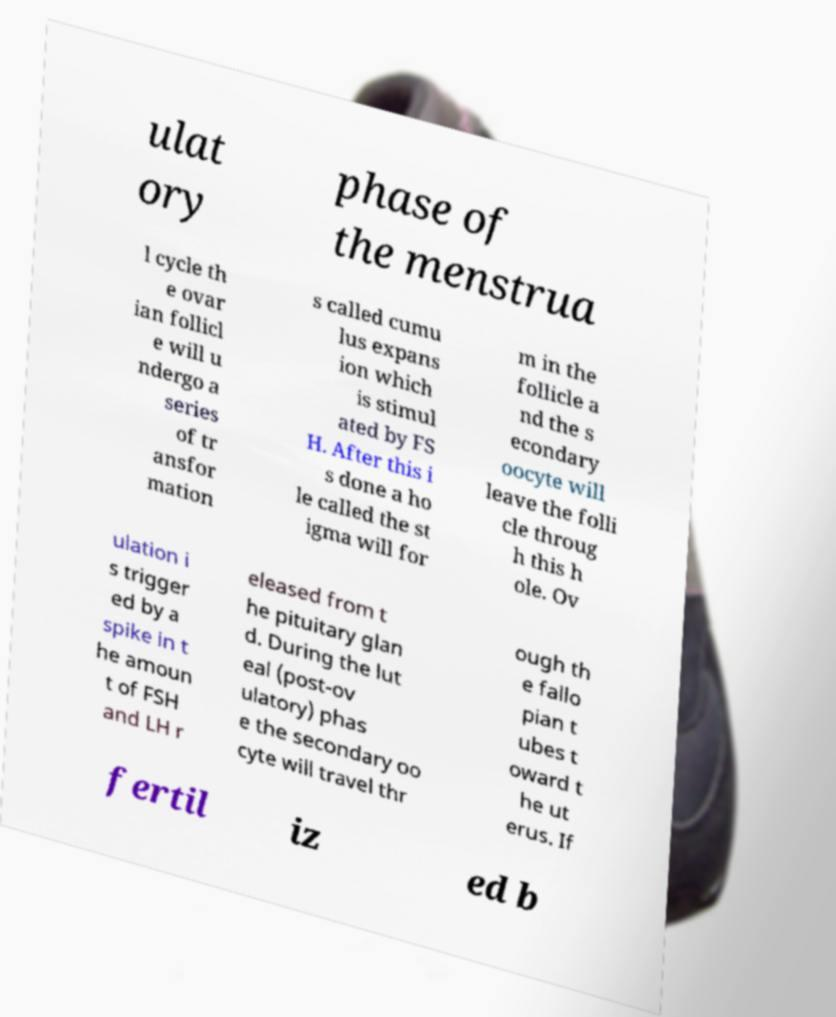Could you extract and type out the text from this image? ulat ory phase of the menstrua l cycle th e ovar ian follicl e will u ndergo a series of tr ansfor mation s called cumu lus expans ion which is stimul ated by FS H. After this i s done a ho le called the st igma will for m in the follicle a nd the s econdary oocyte will leave the folli cle throug h this h ole. Ov ulation i s trigger ed by a spike in t he amoun t of FSH and LH r eleased from t he pituitary glan d. During the lut eal (post-ov ulatory) phas e the secondary oo cyte will travel thr ough th e fallo pian t ubes t oward t he ut erus. If fertil iz ed b 